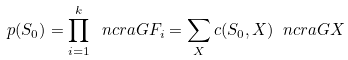<formula> <loc_0><loc_0><loc_500><loc_500>p ( S _ { 0 } ) = \prod _ { i = 1 } ^ { k } \ n c r a { G } { F _ { i } } = \sum _ { X } c ( S _ { 0 } , X ) \ n c r a { G } { X }</formula> 